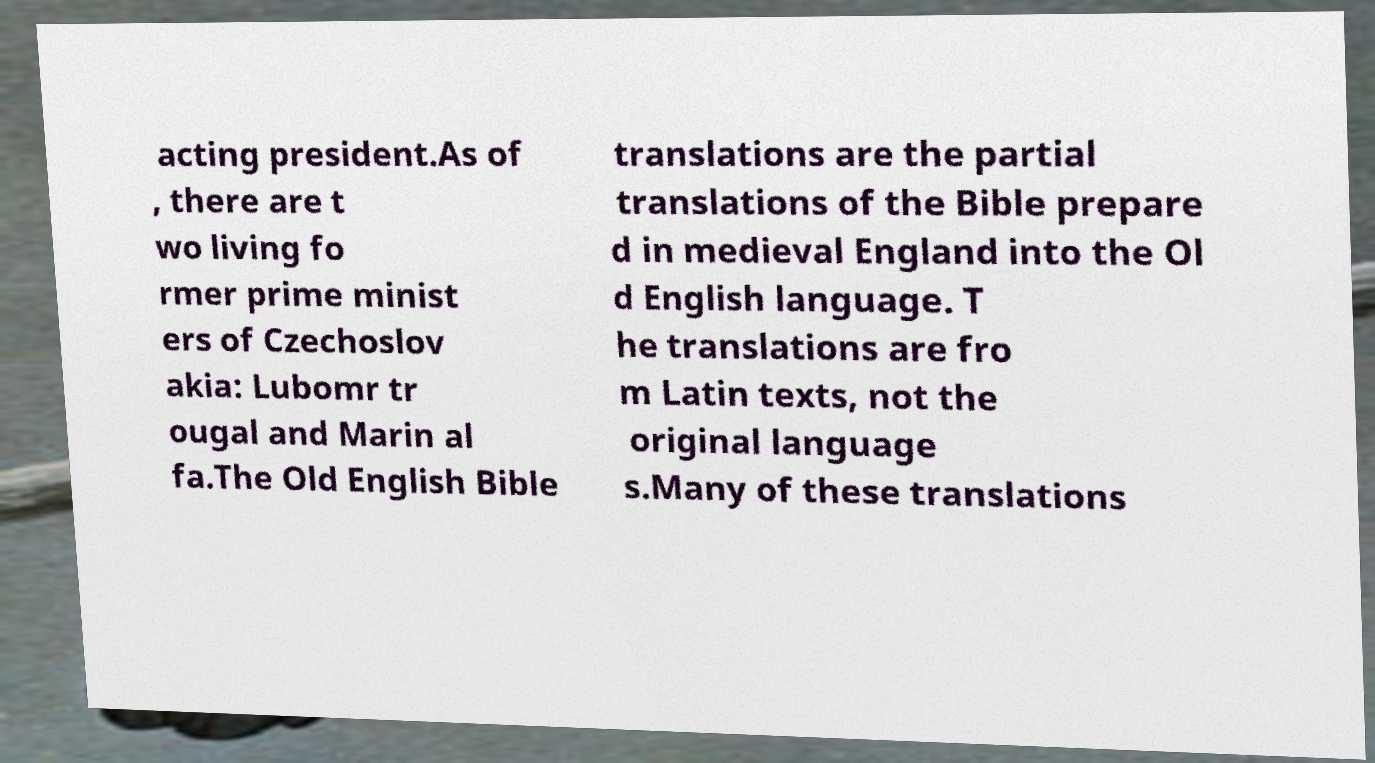Could you assist in decoding the text presented in this image and type it out clearly? acting president.As of , there are t wo living fo rmer prime minist ers of Czechoslov akia: Lubomr tr ougal and Marin al fa.The Old English Bible translations are the partial translations of the Bible prepare d in medieval England into the Ol d English language. T he translations are fro m Latin texts, not the original language s.Many of these translations 